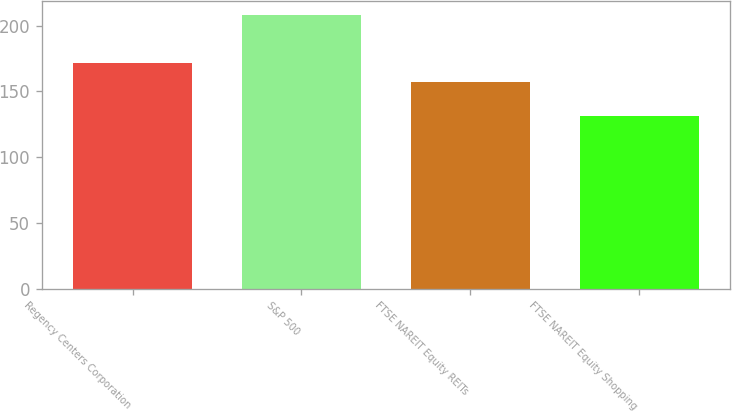<chart> <loc_0><loc_0><loc_500><loc_500><bar_chart><fcel>Regency Centers Corporation<fcel>S&P 500<fcel>FTSE NAREIT Equity REITs<fcel>FTSE NAREIT Equity Shopping<nl><fcel>171.96<fcel>208.14<fcel>157.14<fcel>131.31<nl></chart> 